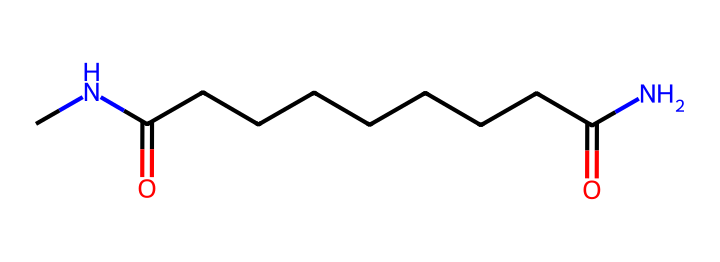what is the main functional group present in this chemical? The structure contains amide groups, characterized by the presence of carbonyl (C=O) adjacent to a nitrogen atom (N), which is typical in nylons.
Answer: amide how many carbon atoms are in the chemical structure? By analyzing the structure, we can count a total of 12 carbon atoms represented in the chain and functional groups.
Answer: 12 what type of polymer is nylon classified as? Nylon is classified as a synthetic polymer because it is created through chemical synthesis, typically involving the polymerization of amide monomers.
Answer: synthetic how does the presence of nitrogen affect the properties of this fiber? The presence of nitrogen, particularly in the amide groups, contributes to the fiber's strength and elasticity by allowing for hydrogen bonding between polymer chains, elevating the overall mechanical properties.
Answer: strength what is the significance of the carbonyl groups in nylon fibers? The carbonyl groups in nylon fibers enhance intermolecular interactions and are crucial for contributing to the stability and durability of the fiber, impacting its use in clothing.
Answer: stability how many double bonds are in the chemical structure? In the provided structure, there is one double bond present in the carbonyl groups, which can be seen in the carbon-oxygen connections.
Answer: one what contributes to the softness of nylon fibers used in costumes? The soft texture of nylon fibers is due to its long chain structure with a balanced amount of polar and nonpolar regions, allowing for flexibility and a smooth feel against the skin.
Answer: flexibility 